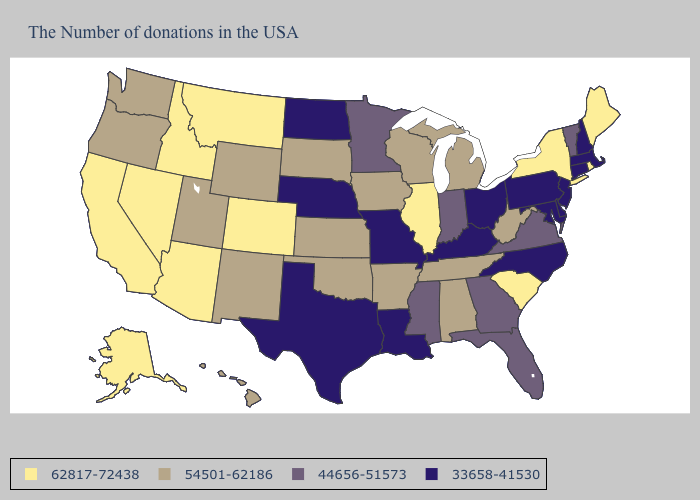What is the highest value in the MidWest ?
Write a very short answer. 62817-72438. Among the states that border Kentucky , does Tennessee have the highest value?
Be succinct. No. What is the value of Texas?
Concise answer only. 33658-41530. Which states have the lowest value in the USA?
Be succinct. Massachusetts, New Hampshire, Connecticut, New Jersey, Delaware, Maryland, Pennsylvania, North Carolina, Ohio, Kentucky, Louisiana, Missouri, Nebraska, Texas, North Dakota. Name the states that have a value in the range 54501-62186?
Write a very short answer. West Virginia, Michigan, Alabama, Tennessee, Wisconsin, Arkansas, Iowa, Kansas, Oklahoma, South Dakota, Wyoming, New Mexico, Utah, Washington, Oregon, Hawaii. Does Pennsylvania have the same value as Alabama?
Concise answer only. No. Is the legend a continuous bar?
Write a very short answer. No. Which states hav the highest value in the West?
Short answer required. Colorado, Montana, Arizona, Idaho, Nevada, California, Alaska. What is the highest value in states that border Arizona?
Write a very short answer. 62817-72438. Name the states that have a value in the range 44656-51573?
Answer briefly. Vermont, Virginia, Florida, Georgia, Indiana, Mississippi, Minnesota. Name the states that have a value in the range 33658-41530?
Keep it brief. Massachusetts, New Hampshire, Connecticut, New Jersey, Delaware, Maryland, Pennsylvania, North Carolina, Ohio, Kentucky, Louisiana, Missouri, Nebraska, Texas, North Dakota. Name the states that have a value in the range 33658-41530?
Write a very short answer. Massachusetts, New Hampshire, Connecticut, New Jersey, Delaware, Maryland, Pennsylvania, North Carolina, Ohio, Kentucky, Louisiana, Missouri, Nebraska, Texas, North Dakota. What is the value of Arizona?
Be succinct. 62817-72438. Which states have the lowest value in the MidWest?
Short answer required. Ohio, Missouri, Nebraska, North Dakota. Name the states that have a value in the range 33658-41530?
Answer briefly. Massachusetts, New Hampshire, Connecticut, New Jersey, Delaware, Maryland, Pennsylvania, North Carolina, Ohio, Kentucky, Louisiana, Missouri, Nebraska, Texas, North Dakota. 